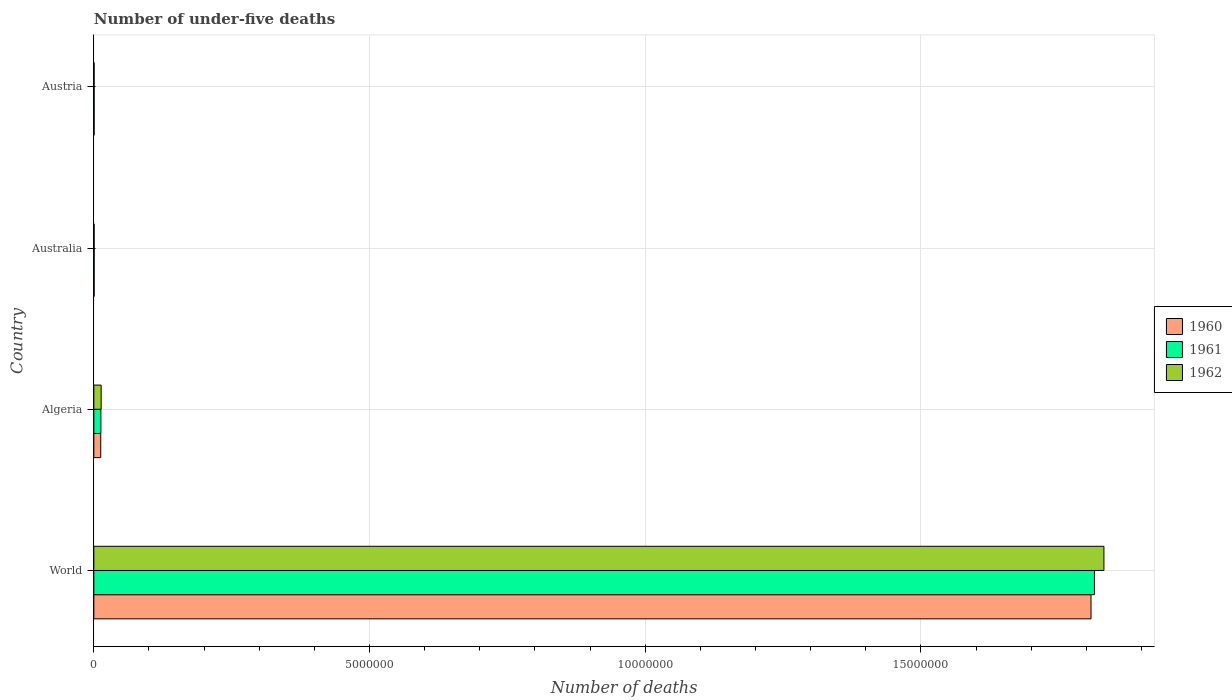How many different coloured bars are there?
Ensure brevity in your answer.  3. How many groups of bars are there?
Give a very brief answer. 4. What is the number of under-five deaths in 1962 in Algeria?
Ensure brevity in your answer.  1.33e+05. Across all countries, what is the maximum number of under-five deaths in 1960?
Make the answer very short. 1.81e+07. Across all countries, what is the minimum number of under-five deaths in 1960?
Keep it short and to the point. 5754. In which country was the number of under-five deaths in 1962 maximum?
Your answer should be compact. World. In which country was the number of under-five deaths in 1961 minimum?
Your answer should be compact. Austria. What is the total number of under-five deaths in 1962 in the graph?
Your response must be concise. 1.85e+07. What is the difference between the number of under-five deaths in 1960 in Algeria and that in Australia?
Offer a very short reply. 1.20e+05. What is the difference between the number of under-five deaths in 1962 in World and the number of under-five deaths in 1961 in Austria?
Provide a succinct answer. 1.83e+07. What is the average number of under-five deaths in 1961 per country?
Your answer should be compact. 4.57e+06. What is the difference between the number of under-five deaths in 1961 and number of under-five deaths in 1962 in Australia?
Keep it short and to the point. 130. In how many countries, is the number of under-five deaths in 1962 greater than 18000000 ?
Give a very brief answer. 1. What is the ratio of the number of under-five deaths in 1960 in Australia to that in World?
Make the answer very short. 0. Is the difference between the number of under-five deaths in 1961 in Algeria and Austria greater than the difference between the number of under-five deaths in 1962 in Algeria and Austria?
Keep it short and to the point. No. What is the difference between the highest and the second highest number of under-five deaths in 1962?
Offer a terse response. 1.82e+07. What is the difference between the highest and the lowest number of under-five deaths in 1960?
Your answer should be compact. 1.81e+07. What does the 3rd bar from the bottom in World represents?
Make the answer very short. 1962. Is it the case that in every country, the sum of the number of under-five deaths in 1962 and number of under-five deaths in 1960 is greater than the number of under-five deaths in 1961?
Provide a succinct answer. Yes. How many bars are there?
Provide a succinct answer. 12. How many countries are there in the graph?
Make the answer very short. 4. Are the values on the major ticks of X-axis written in scientific E-notation?
Ensure brevity in your answer.  No. Where does the legend appear in the graph?
Your answer should be very brief. Center right. What is the title of the graph?
Offer a very short reply. Number of under-five deaths. What is the label or title of the X-axis?
Offer a very short reply. Number of deaths. What is the label or title of the Y-axis?
Your answer should be very brief. Country. What is the Number of deaths in 1960 in World?
Give a very brief answer. 1.81e+07. What is the Number of deaths of 1961 in World?
Your answer should be compact. 1.81e+07. What is the Number of deaths of 1962 in World?
Keep it short and to the point. 1.83e+07. What is the Number of deaths of 1960 in Algeria?
Provide a short and direct response. 1.25e+05. What is the Number of deaths in 1961 in Algeria?
Ensure brevity in your answer.  1.28e+05. What is the Number of deaths in 1962 in Algeria?
Provide a short and direct response. 1.33e+05. What is the Number of deaths of 1960 in Australia?
Your answer should be compact. 5775. What is the Number of deaths of 1961 in Australia?
Your answer should be compact. 5722. What is the Number of deaths of 1962 in Australia?
Your answer should be very brief. 5592. What is the Number of deaths of 1960 in Austria?
Your answer should be compact. 5754. What is the Number of deaths in 1961 in Austria?
Keep it short and to the point. 5502. What is the Number of deaths of 1962 in Austria?
Give a very brief answer. 5183. Across all countries, what is the maximum Number of deaths in 1960?
Make the answer very short. 1.81e+07. Across all countries, what is the maximum Number of deaths in 1961?
Give a very brief answer. 1.81e+07. Across all countries, what is the maximum Number of deaths of 1962?
Your answer should be very brief. 1.83e+07. Across all countries, what is the minimum Number of deaths in 1960?
Provide a short and direct response. 5754. Across all countries, what is the minimum Number of deaths in 1961?
Give a very brief answer. 5502. Across all countries, what is the minimum Number of deaths of 1962?
Provide a succinct answer. 5183. What is the total Number of deaths of 1960 in the graph?
Your answer should be very brief. 1.82e+07. What is the total Number of deaths in 1961 in the graph?
Make the answer very short. 1.83e+07. What is the total Number of deaths of 1962 in the graph?
Give a very brief answer. 1.85e+07. What is the difference between the Number of deaths of 1960 in World and that in Algeria?
Keep it short and to the point. 1.80e+07. What is the difference between the Number of deaths in 1961 in World and that in Algeria?
Your answer should be compact. 1.80e+07. What is the difference between the Number of deaths in 1962 in World and that in Algeria?
Make the answer very short. 1.82e+07. What is the difference between the Number of deaths of 1960 in World and that in Australia?
Your answer should be compact. 1.81e+07. What is the difference between the Number of deaths of 1961 in World and that in Australia?
Your answer should be compact. 1.81e+07. What is the difference between the Number of deaths in 1962 in World and that in Australia?
Provide a succinct answer. 1.83e+07. What is the difference between the Number of deaths of 1960 in World and that in Austria?
Provide a short and direct response. 1.81e+07. What is the difference between the Number of deaths of 1961 in World and that in Austria?
Your response must be concise. 1.81e+07. What is the difference between the Number of deaths of 1962 in World and that in Austria?
Provide a succinct answer. 1.83e+07. What is the difference between the Number of deaths of 1960 in Algeria and that in Australia?
Your response must be concise. 1.20e+05. What is the difference between the Number of deaths of 1961 in Algeria and that in Australia?
Ensure brevity in your answer.  1.23e+05. What is the difference between the Number of deaths of 1962 in Algeria and that in Australia?
Make the answer very short. 1.27e+05. What is the difference between the Number of deaths in 1960 in Algeria and that in Austria?
Offer a terse response. 1.20e+05. What is the difference between the Number of deaths of 1961 in Algeria and that in Austria?
Offer a terse response. 1.23e+05. What is the difference between the Number of deaths in 1962 in Algeria and that in Austria?
Offer a very short reply. 1.28e+05. What is the difference between the Number of deaths in 1961 in Australia and that in Austria?
Make the answer very short. 220. What is the difference between the Number of deaths of 1962 in Australia and that in Austria?
Keep it short and to the point. 409. What is the difference between the Number of deaths of 1960 in World and the Number of deaths of 1961 in Algeria?
Your answer should be compact. 1.80e+07. What is the difference between the Number of deaths in 1960 in World and the Number of deaths in 1962 in Algeria?
Offer a very short reply. 1.80e+07. What is the difference between the Number of deaths of 1961 in World and the Number of deaths of 1962 in Algeria?
Ensure brevity in your answer.  1.80e+07. What is the difference between the Number of deaths in 1960 in World and the Number of deaths in 1961 in Australia?
Offer a very short reply. 1.81e+07. What is the difference between the Number of deaths of 1960 in World and the Number of deaths of 1962 in Australia?
Keep it short and to the point. 1.81e+07. What is the difference between the Number of deaths of 1961 in World and the Number of deaths of 1962 in Australia?
Offer a terse response. 1.81e+07. What is the difference between the Number of deaths in 1960 in World and the Number of deaths in 1961 in Austria?
Your response must be concise. 1.81e+07. What is the difference between the Number of deaths in 1960 in World and the Number of deaths in 1962 in Austria?
Your answer should be compact. 1.81e+07. What is the difference between the Number of deaths in 1961 in World and the Number of deaths in 1962 in Austria?
Your answer should be compact. 1.81e+07. What is the difference between the Number of deaths of 1960 in Algeria and the Number of deaths of 1961 in Australia?
Your response must be concise. 1.20e+05. What is the difference between the Number of deaths of 1960 in Algeria and the Number of deaths of 1962 in Australia?
Ensure brevity in your answer.  1.20e+05. What is the difference between the Number of deaths in 1961 in Algeria and the Number of deaths in 1962 in Australia?
Keep it short and to the point. 1.23e+05. What is the difference between the Number of deaths in 1960 in Algeria and the Number of deaths in 1961 in Austria?
Your response must be concise. 1.20e+05. What is the difference between the Number of deaths in 1960 in Algeria and the Number of deaths in 1962 in Austria?
Ensure brevity in your answer.  1.20e+05. What is the difference between the Number of deaths of 1961 in Algeria and the Number of deaths of 1962 in Austria?
Give a very brief answer. 1.23e+05. What is the difference between the Number of deaths of 1960 in Australia and the Number of deaths of 1961 in Austria?
Ensure brevity in your answer.  273. What is the difference between the Number of deaths of 1960 in Australia and the Number of deaths of 1962 in Austria?
Offer a terse response. 592. What is the difference between the Number of deaths of 1961 in Australia and the Number of deaths of 1962 in Austria?
Offer a very short reply. 539. What is the average Number of deaths of 1960 per country?
Make the answer very short. 4.56e+06. What is the average Number of deaths of 1961 per country?
Your answer should be very brief. 4.57e+06. What is the average Number of deaths in 1962 per country?
Your answer should be very brief. 4.62e+06. What is the difference between the Number of deaths in 1960 and Number of deaths in 1961 in World?
Your answer should be very brief. -6.21e+04. What is the difference between the Number of deaths in 1960 and Number of deaths in 1962 in World?
Keep it short and to the point. -2.34e+05. What is the difference between the Number of deaths of 1961 and Number of deaths of 1962 in World?
Make the answer very short. -1.72e+05. What is the difference between the Number of deaths in 1960 and Number of deaths in 1961 in Algeria?
Your answer should be compact. -2789. What is the difference between the Number of deaths in 1960 and Number of deaths in 1962 in Algeria?
Provide a succinct answer. -7580. What is the difference between the Number of deaths of 1961 and Number of deaths of 1962 in Algeria?
Your answer should be very brief. -4791. What is the difference between the Number of deaths in 1960 and Number of deaths in 1962 in Australia?
Your answer should be compact. 183. What is the difference between the Number of deaths in 1961 and Number of deaths in 1962 in Australia?
Offer a very short reply. 130. What is the difference between the Number of deaths of 1960 and Number of deaths of 1961 in Austria?
Offer a very short reply. 252. What is the difference between the Number of deaths in 1960 and Number of deaths in 1962 in Austria?
Ensure brevity in your answer.  571. What is the difference between the Number of deaths of 1961 and Number of deaths of 1962 in Austria?
Offer a terse response. 319. What is the ratio of the Number of deaths of 1960 in World to that in Algeria?
Your answer should be compact. 144.14. What is the ratio of the Number of deaths in 1961 in World to that in Algeria?
Keep it short and to the point. 141.49. What is the ratio of the Number of deaths of 1962 in World to that in Algeria?
Your response must be concise. 137.69. What is the ratio of the Number of deaths of 1960 in World to that in Australia?
Your answer should be compact. 3131.31. What is the ratio of the Number of deaths in 1961 in World to that in Australia?
Your answer should be very brief. 3171.17. What is the ratio of the Number of deaths of 1962 in World to that in Australia?
Give a very brief answer. 3275.65. What is the ratio of the Number of deaths of 1960 in World to that in Austria?
Your answer should be compact. 3142.74. What is the ratio of the Number of deaths in 1961 in World to that in Austria?
Your response must be concise. 3297.97. What is the ratio of the Number of deaths of 1962 in World to that in Austria?
Provide a short and direct response. 3534.14. What is the ratio of the Number of deaths in 1960 in Algeria to that in Australia?
Give a very brief answer. 21.72. What is the ratio of the Number of deaths of 1961 in Algeria to that in Australia?
Offer a terse response. 22.41. What is the ratio of the Number of deaths of 1962 in Algeria to that in Australia?
Provide a succinct answer. 23.79. What is the ratio of the Number of deaths of 1960 in Algeria to that in Austria?
Offer a very short reply. 21.8. What is the ratio of the Number of deaths of 1961 in Algeria to that in Austria?
Your response must be concise. 23.31. What is the ratio of the Number of deaths in 1962 in Algeria to that in Austria?
Ensure brevity in your answer.  25.67. What is the ratio of the Number of deaths of 1960 in Australia to that in Austria?
Make the answer very short. 1. What is the ratio of the Number of deaths in 1962 in Australia to that in Austria?
Ensure brevity in your answer.  1.08. What is the difference between the highest and the second highest Number of deaths of 1960?
Offer a terse response. 1.80e+07. What is the difference between the highest and the second highest Number of deaths in 1961?
Your response must be concise. 1.80e+07. What is the difference between the highest and the second highest Number of deaths in 1962?
Your response must be concise. 1.82e+07. What is the difference between the highest and the lowest Number of deaths of 1960?
Offer a very short reply. 1.81e+07. What is the difference between the highest and the lowest Number of deaths in 1961?
Make the answer very short. 1.81e+07. What is the difference between the highest and the lowest Number of deaths in 1962?
Your answer should be compact. 1.83e+07. 